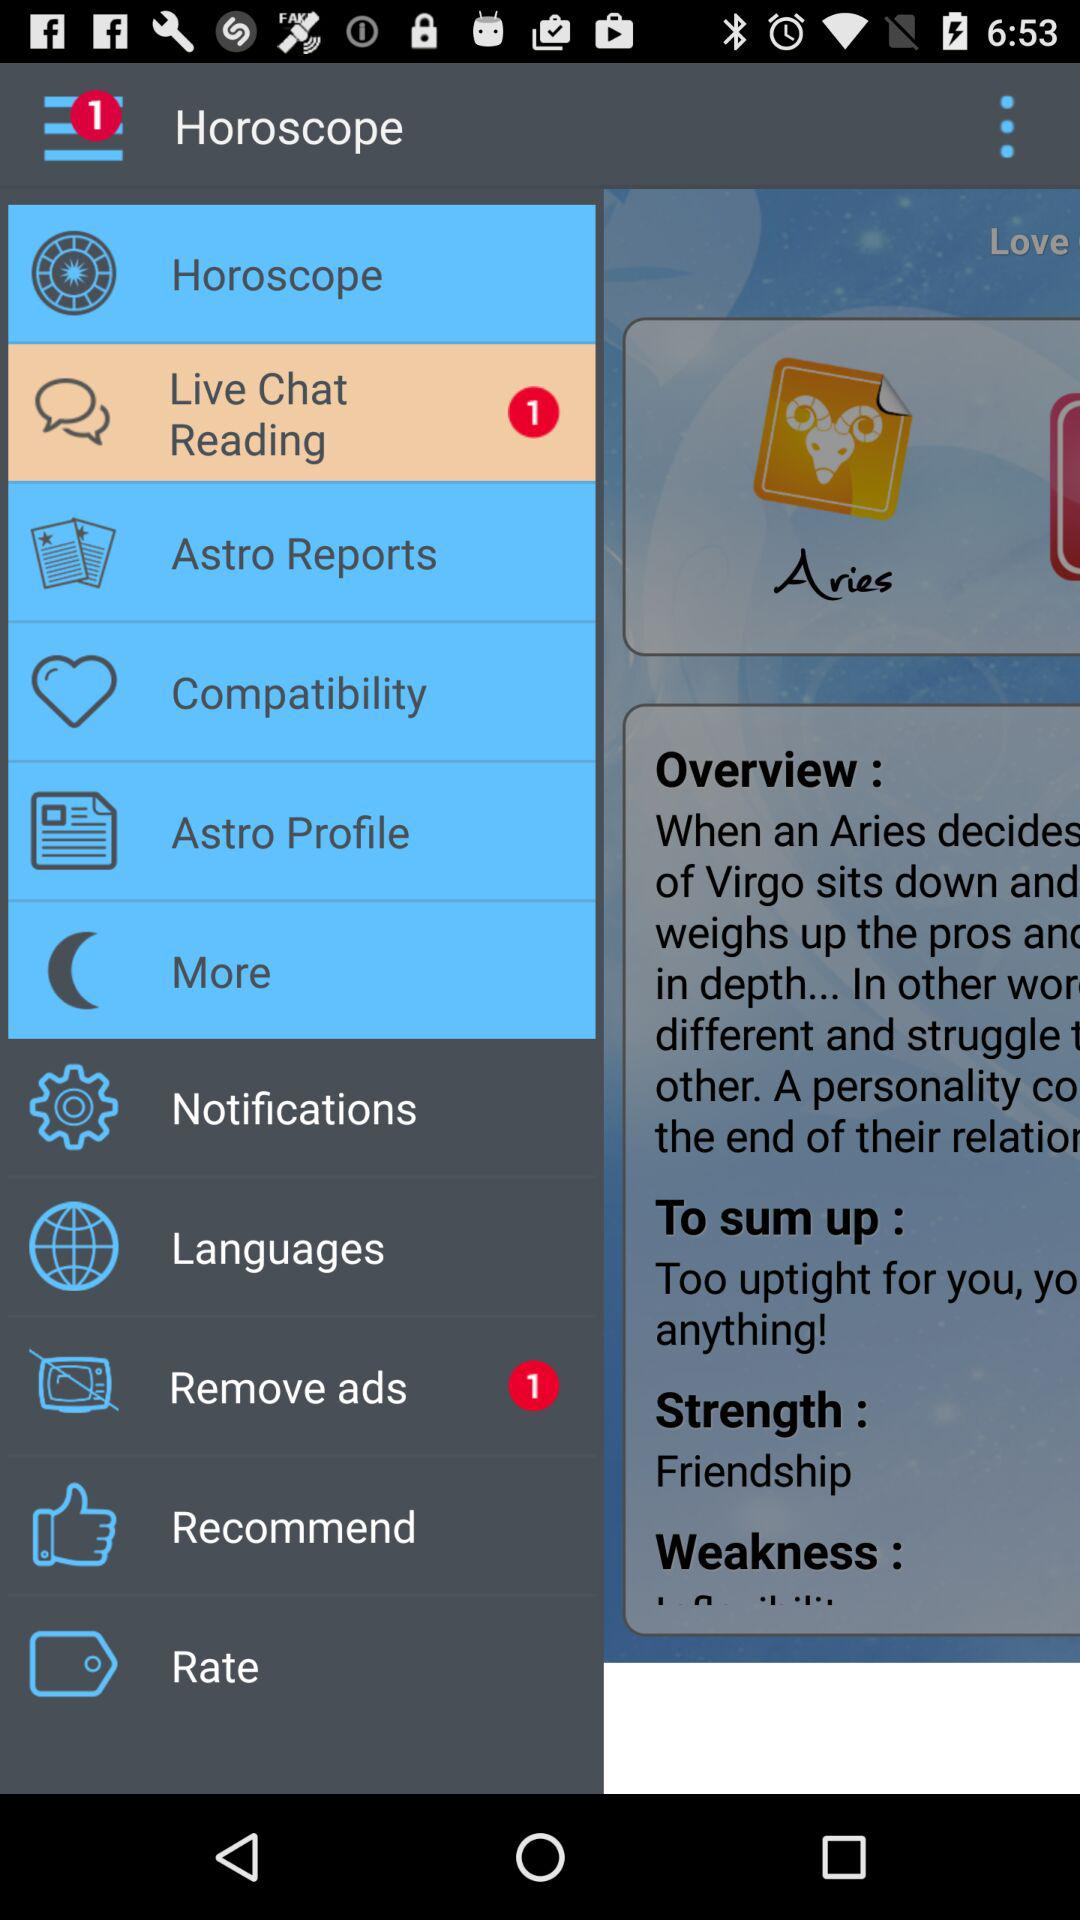How many notifications are there in "Horoscope"?
When the provided information is insufficient, respond with <no answer>. <no answer> 